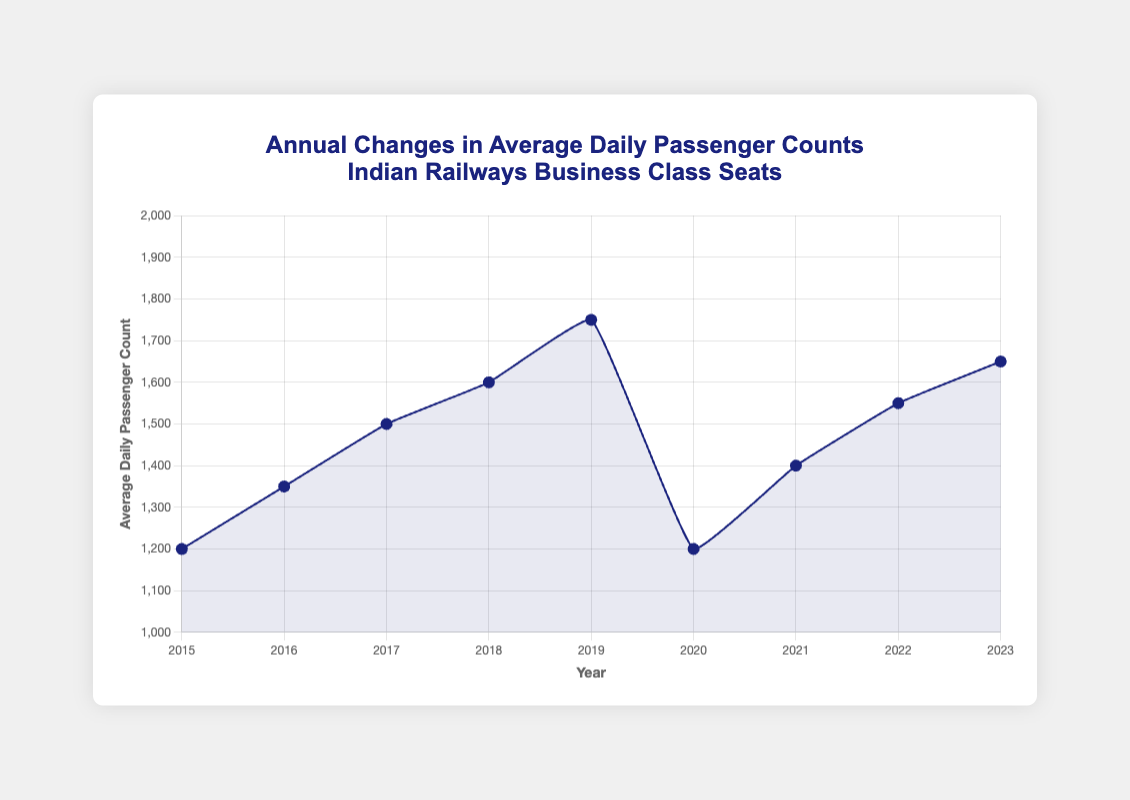What was the highest average daily passenger count recorded between 2015 and 2023? The highest average daily passenger count is found by inspecting the highest point on the line chart. This occurs in 2019, where the count is 1750.
Answer: 1750 How did the average daily passenger count change from 2019 to 2020? To find the change, subtract the count in 2020 (1200) from the count in 2019 (1750). 1750 - 1200 = 550. This represents a decrease of 550.
Answer: Decreased by 550 Which years observed an increase in average daily passenger count compared to the previous year? Compare the values year by year to check which ones increased. The increases occurred from 2015 to 2016, 2016 to 2017, 2017 to 2018, 2018 to 2019, 2020 to 2021, 2021 to 2022, and 2022 to 2023.
Answer: 2016, 2017, 2018, 2019, 2021, 2022, 2023 What is the average daily passenger count for the year when COVID-19 had an impact? Use the annotation to identify the COVID-19 impact year 2020 with an average count of 1200.
Answer: 1200 Was there a significant recovery in passenger counts after 2020? If yes, by how much did the count change by 2021? Compare the counts of 2020 and 2021. The count in 2021 is 1400 and it was 1200 in 2020. The change is 1400 - 1200 = 200, indicating recovery.
Answer: Increased by 200 Between which years did the largest increase in average daily passenger counts occur? By calculating the differences, the largest increase was from 2020 (1200) to 2021 (1400), a difference of 200 passengers.
Answer: 2020 to 2021 How many years have higher average daily passenger counts than the initial year (2015)? Compare each year’s count to 2015’s count of 1200. The counts in 2016, 2017, 2018, 2019, 2021, 2022, and 2023 are all higher. This totals to 7 years.
Answer: 7 years When were new routes added and what was the average daily passenger count that year? Annotate the year “New routes added” which is 2018, with an average daily passenger count of 1600.
Answer: 2018, 1600 How did the average daily passenger count change from the introduction of premium service trains to the beginning of the COVID-19 pandemic? Premium services started in 2015 (1200 passengers) and COVID-19 impacted 2020 (1200 passengers). The count stayed the same.
Answer: No change 